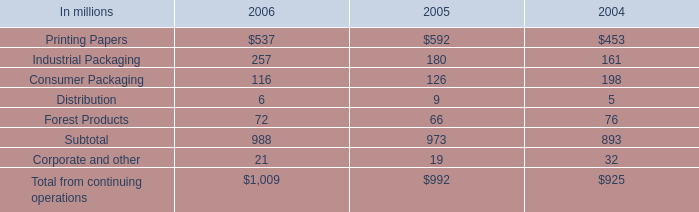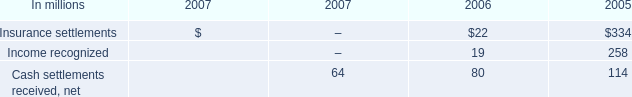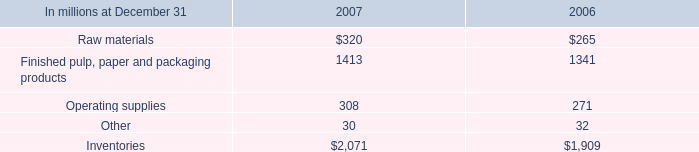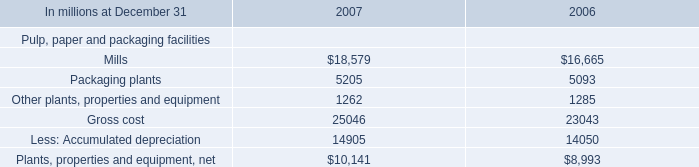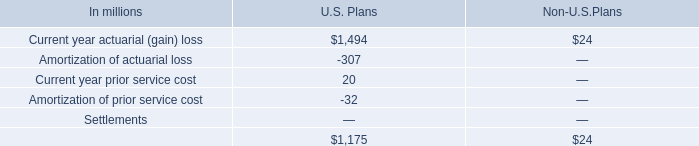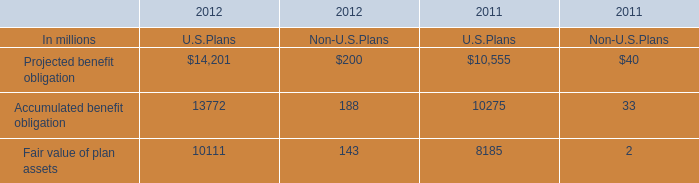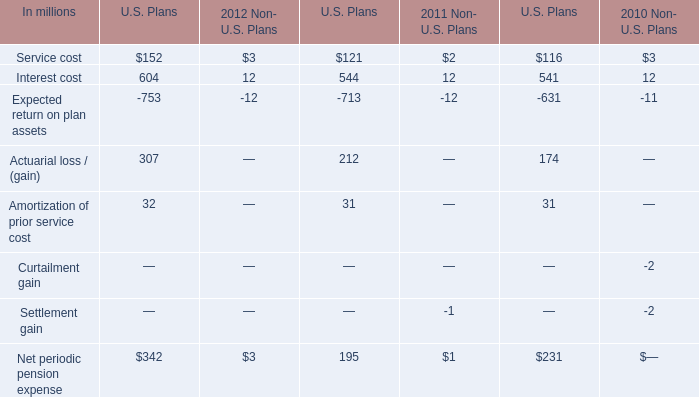what's the total amount of Gross cost of 2007, Fair value of plan assets of 2011 U.S.Plans, and Mills of 2007 ? 
Computations: ((25046.0 + 8185.0) + 18579.0)
Answer: 51810.0. 